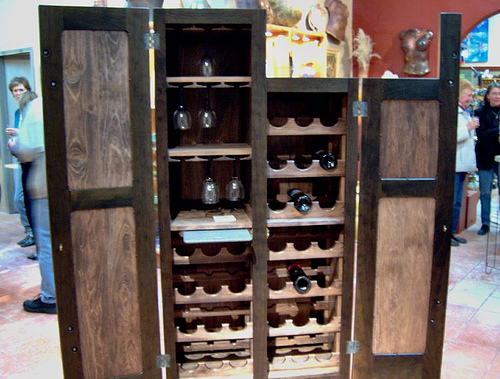<image>
Is the door in front of the shelves? No. The door is not in front of the shelves. The spatial positioning shows a different relationship between these objects. 